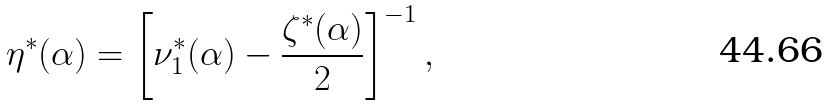Convert formula to latex. <formula><loc_0><loc_0><loc_500><loc_500>\eta ^ { * } ( \alpha ) = \left [ \nu ^ { * } _ { 1 } ( \alpha ) - \frac { \zeta ^ { * } ( \alpha ) } { 2 } \right ] ^ { - 1 } ,</formula> 